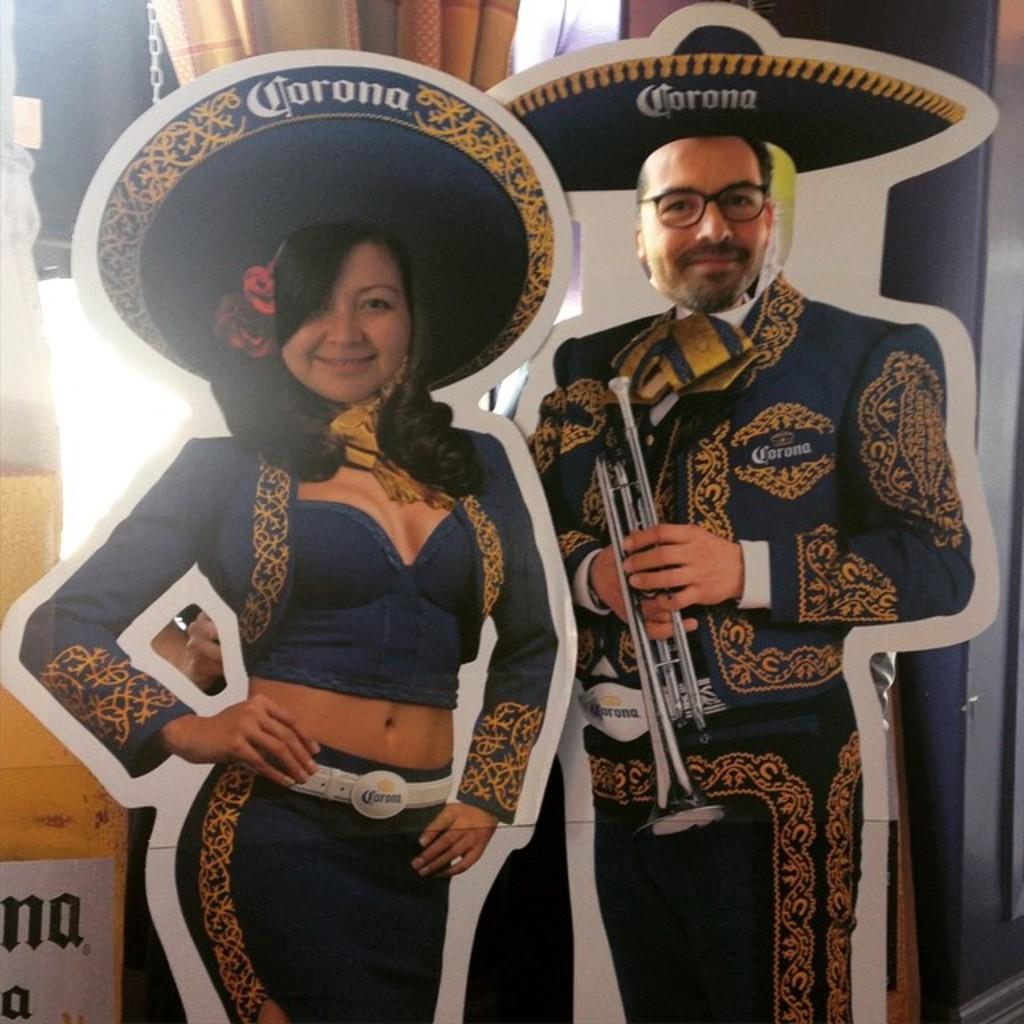Please provide a concise description of this image. In this picture we can see cardboard poster, behind that we can see original faces. On the back we can see window, cloth and other objects. On the bottom left corner there is a wooden box. 